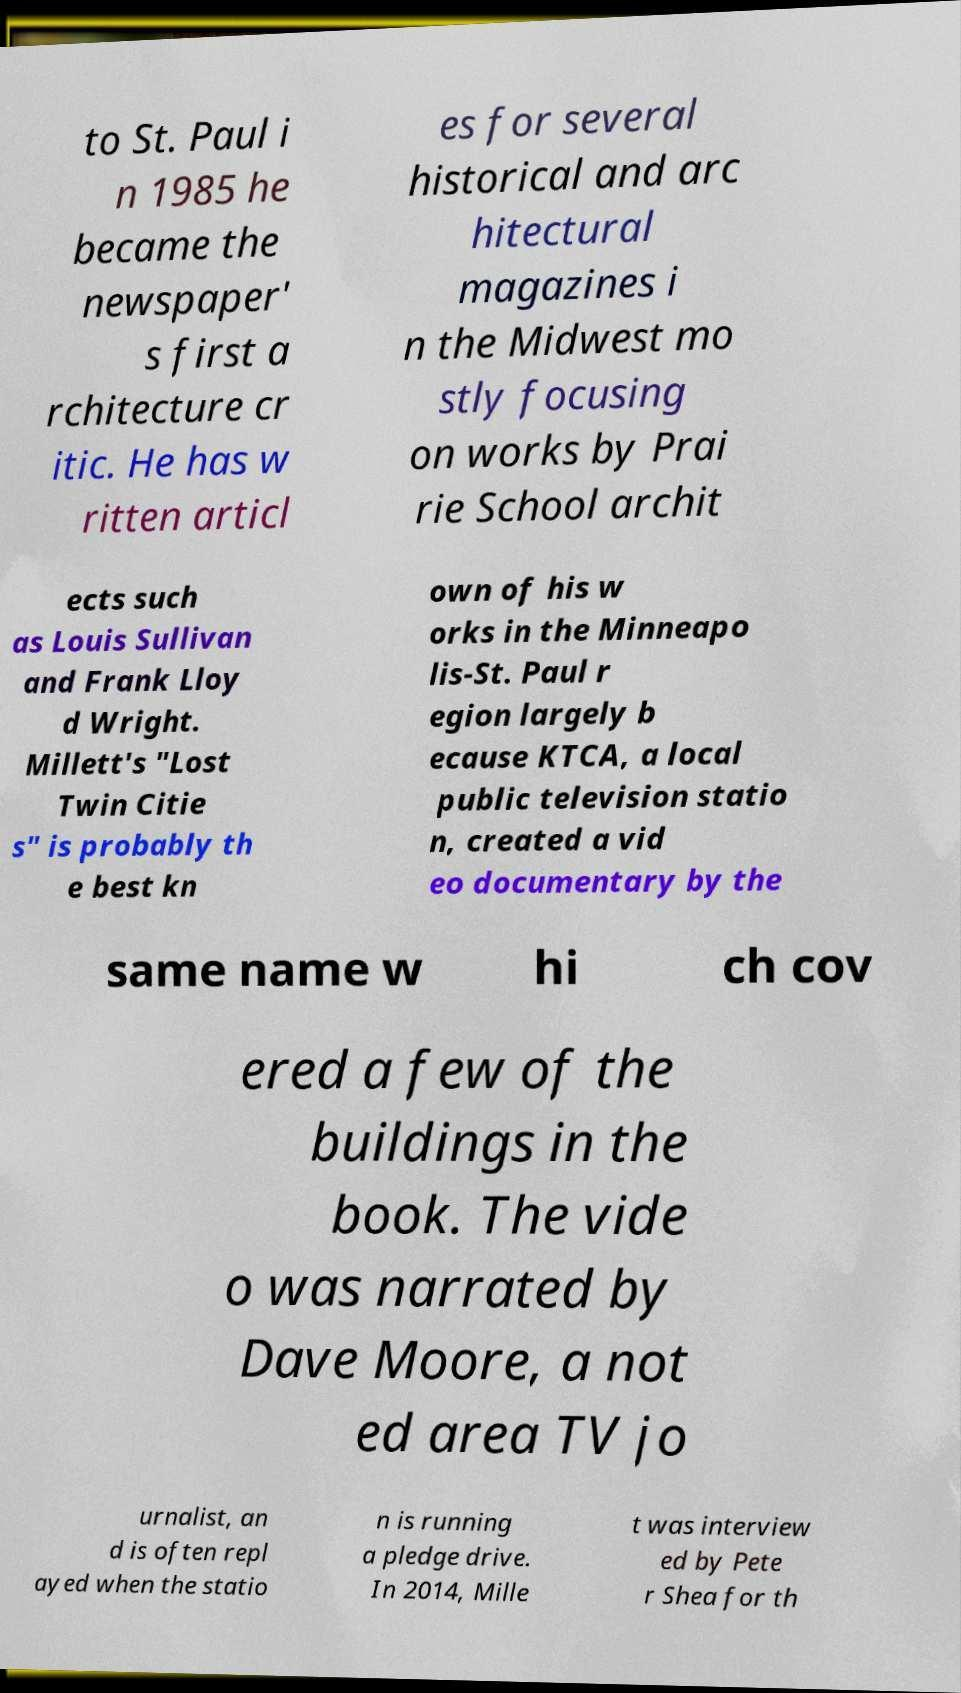I need the written content from this picture converted into text. Can you do that? to St. Paul i n 1985 he became the newspaper' s first a rchitecture cr itic. He has w ritten articl es for several historical and arc hitectural magazines i n the Midwest mo stly focusing on works by Prai rie School archit ects such as Louis Sullivan and Frank Lloy d Wright. Millett's "Lost Twin Citie s" is probably th e best kn own of his w orks in the Minneapo lis-St. Paul r egion largely b ecause KTCA, a local public television statio n, created a vid eo documentary by the same name w hi ch cov ered a few of the buildings in the book. The vide o was narrated by Dave Moore, a not ed area TV jo urnalist, an d is often repl ayed when the statio n is running a pledge drive. In 2014, Mille t was interview ed by Pete r Shea for th 